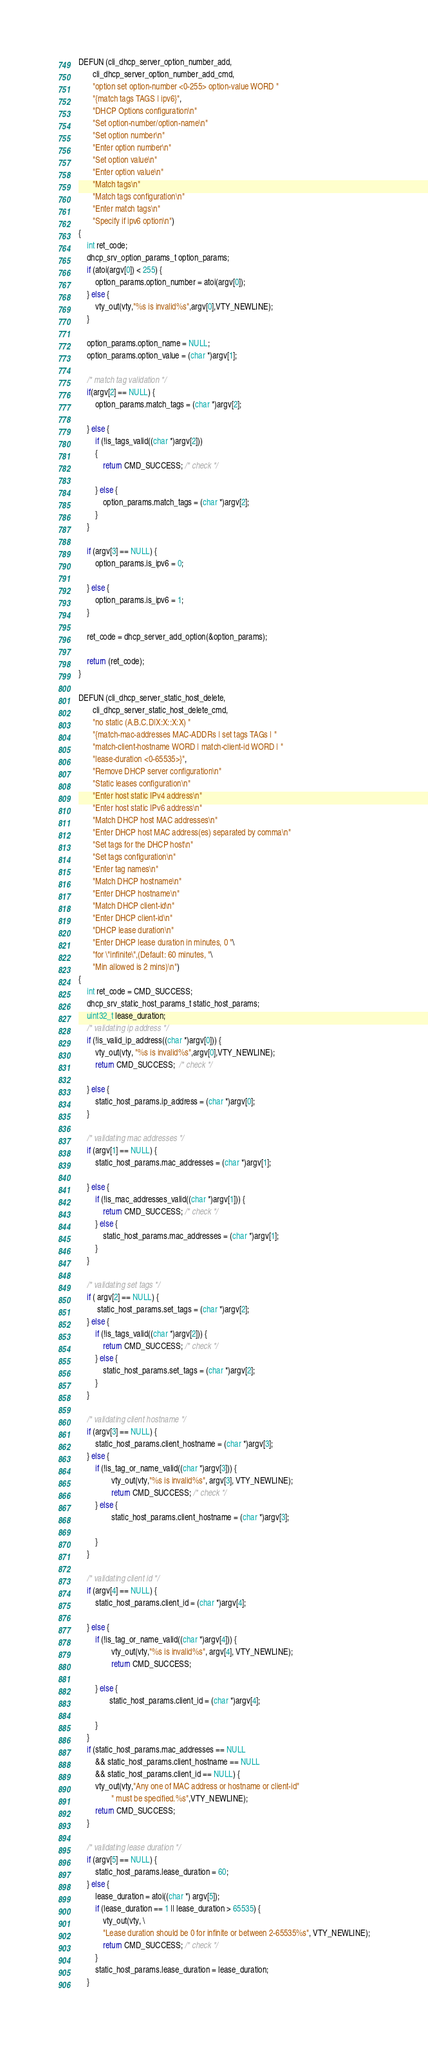<code> <loc_0><loc_0><loc_500><loc_500><_C_>
DEFUN (cli_dhcp_server_option_number_add,
       cli_dhcp_server_option_number_add_cmd,
       "option set option-number <0-255> option-value WORD "
       "{match tags TAGS | ipv6}",
       "DHCP Options configuration\n"
       "Set option-number/option-name\n"
       "Set option number\n"
       "Enter option number\n"
       "Set option value\n"
       "Enter option value\n"
       "Match tags\n"
       "Match tags configuration\n"
       "Enter match tags\n"
       "Specify if ipv6 option\n")
{
    int ret_code;
    dhcp_srv_option_params_t option_params;
    if (atoi(argv[0]) < 255) {
        option_params.option_number = atoi(argv[0]);
    } else {
        vty_out(vty,"%s is invalid%s",argv[0],VTY_NEWLINE);
    }

    option_params.option_name = NULL;
    option_params.option_value = (char *)argv[1];

    /* match tag validation */
    if(argv[2] == NULL) {
        option_params.match_tags = (char *)argv[2];

    } else {
        if (!is_tags_valid((char *)argv[2]))
        {
            return CMD_SUCCESS; /* check */

        } else {
            option_params.match_tags = (char *)argv[2];
        }
    }

    if (argv[3] == NULL) {
        option_params.is_ipv6 = 0;

    } else {
        option_params.is_ipv6 = 1;
    }

    ret_code = dhcp_server_add_option(&option_params);

    return (ret_code);
}

DEFUN (cli_dhcp_server_static_host_delete,
       cli_dhcp_server_static_host_delete_cmd,
       "no static (A.B.C.D|X:X::X:X) "
       "{match-mac-addresses MAC-ADDRs | set tags TAGs | "
       "match-client-hostname WORD | match-client-id WORD | "
       "lease-duration <0-65535>}",
       "Remove DHCP server configuration\n"
       "Static leases configuration\n"
       "Enter host static IPv4 address\n"
       "Enter host static IPv6 address\n"
       "Match DHCP host MAC addresses\n"
       "Enter DHCP host MAC address(es) separated by comma\n"
       "Set tags for the DHCP host\n"
       "Set tags configuration\n"
       "Enter tag names\n"
       "Match DHCP hostname\n"
       "Enter DHCP hostname\n"
       "Match DHCP client-id\n"
       "Enter DHCP client-id\n"
       "DHCP lease duration\n"
       "Enter DHCP lease duration in minutes, 0 "\
       "for \"infinite\",(Default: 60 minutes, "\
       "Min allowed is 2 mins)\n")
{
    int ret_code = CMD_SUCCESS;
    dhcp_srv_static_host_params_t static_host_params;
    uint32_t lease_duration;
    /* validating ip address */
    if (!is_valid_ip_address((char *)argv[0])) {
        vty_out(vty, "%s is invalid%s",argv[0],VTY_NEWLINE);
        return CMD_SUCCESS;  /* check */

    } else {
        static_host_params.ip_address = (char *)argv[0];
    }

    /* validating mac addresses */
    if (argv[1] == NULL) {
        static_host_params.mac_addresses = (char *)argv[1];

    } else {
        if (!is_mac_addresses_valid((char *)argv[1])) {
            return CMD_SUCCESS; /* check */
        } else {
            static_host_params.mac_addresses = (char *)argv[1];
        }
    }

    /* validating set tags */
    if ( argv[2] == NULL) {
         static_host_params.set_tags = (char *)argv[2];
    } else {
        if (!is_tags_valid((char *)argv[2])) {
            return CMD_SUCCESS; /* check */
        } else {
            static_host_params.set_tags = (char *)argv[2];
        }
    }

    /* validating client hostname */
    if (argv[3] == NULL) {
        static_host_params.client_hostname = (char *)argv[3];
    } else {
        if (!is_tag_or_name_valid((char *)argv[3])) {
                vty_out(vty,"%s is invalid%s", argv[3], VTY_NEWLINE);
                return CMD_SUCCESS; /* check */
        } else {
                static_host_params.client_hostname = (char *)argv[3];

        }
    }

    /* validating client id */
    if (argv[4] == NULL) {
        static_host_params.client_id = (char *)argv[4];

    } else {
        if (!is_tag_or_name_valid((char *)argv[4])) {
                vty_out(vty,"%s is invalid%s", argv[4], VTY_NEWLINE);
                return CMD_SUCCESS;

        } else {
               static_host_params.client_id = (char *)argv[4];

        }
    }
    if (static_host_params.mac_addresses == NULL
        && static_host_params.client_hostname == NULL
        && static_host_params.client_id == NULL) {
        vty_out(vty,"Any one of MAC address or hostname or client-id"
                " must be specified.%s",VTY_NEWLINE);
        return CMD_SUCCESS;
    }

    /* validating lease duration */
    if (argv[5] == NULL) {
        static_host_params.lease_duration = 60;
    } else {
        lease_duration = atoi((char *) argv[5]);
        if (lease_duration == 1 || lease_duration > 65535) {
            vty_out(vty, \
            "Lease duration should be 0 for infinite or between 2-65535%s", VTY_NEWLINE);
            return CMD_SUCCESS; /* check */
        }
        static_host_params.lease_duration = lease_duration;
    }
</code> 